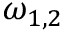Convert formula to latex. <formula><loc_0><loc_0><loc_500><loc_500>\omega _ { 1 , 2 }</formula> 